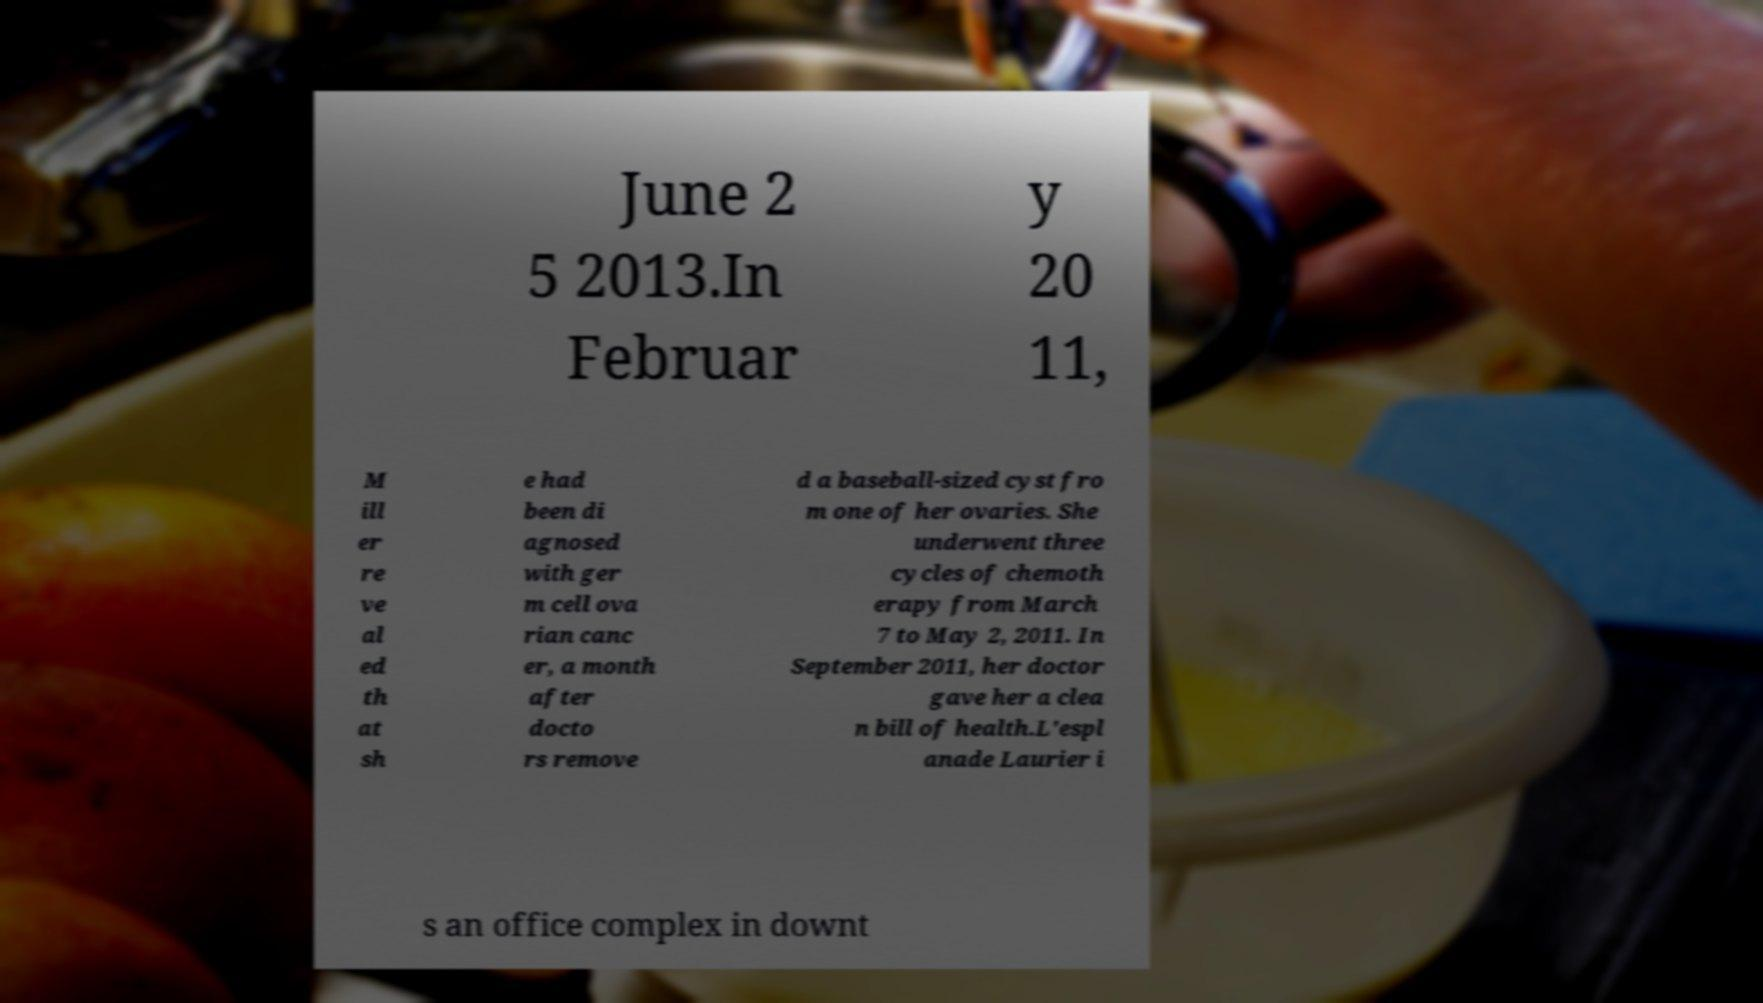For documentation purposes, I need the text within this image transcribed. Could you provide that? June 2 5 2013.In Februar y 20 11, M ill er re ve al ed th at sh e had been di agnosed with ger m cell ova rian canc er, a month after docto rs remove d a baseball-sized cyst fro m one of her ovaries. She underwent three cycles of chemoth erapy from March 7 to May 2, 2011. In September 2011, her doctor gave her a clea n bill of health.L'espl anade Laurier i s an office complex in downt 